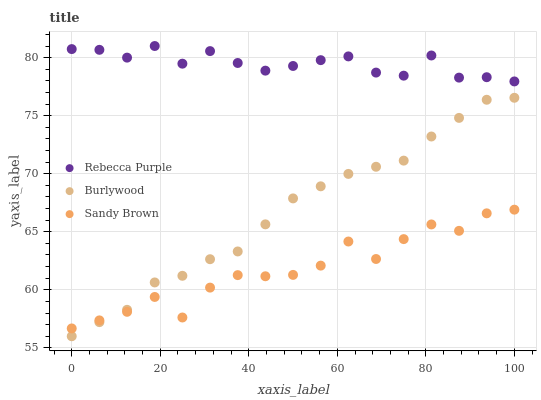Does Sandy Brown have the minimum area under the curve?
Answer yes or no. Yes. Does Rebecca Purple have the maximum area under the curve?
Answer yes or no. Yes. Does Rebecca Purple have the minimum area under the curve?
Answer yes or no. No. Does Sandy Brown have the maximum area under the curve?
Answer yes or no. No. Is Burlywood the smoothest?
Answer yes or no. Yes. Is Sandy Brown the roughest?
Answer yes or no. Yes. Is Rebecca Purple the smoothest?
Answer yes or no. No. Is Rebecca Purple the roughest?
Answer yes or no. No. Does Burlywood have the lowest value?
Answer yes or no. Yes. Does Sandy Brown have the lowest value?
Answer yes or no. No. Does Rebecca Purple have the highest value?
Answer yes or no. Yes. Does Sandy Brown have the highest value?
Answer yes or no. No. Is Burlywood less than Rebecca Purple?
Answer yes or no. Yes. Is Rebecca Purple greater than Sandy Brown?
Answer yes or no. Yes. Does Burlywood intersect Sandy Brown?
Answer yes or no. Yes. Is Burlywood less than Sandy Brown?
Answer yes or no. No. Is Burlywood greater than Sandy Brown?
Answer yes or no. No. Does Burlywood intersect Rebecca Purple?
Answer yes or no. No. 